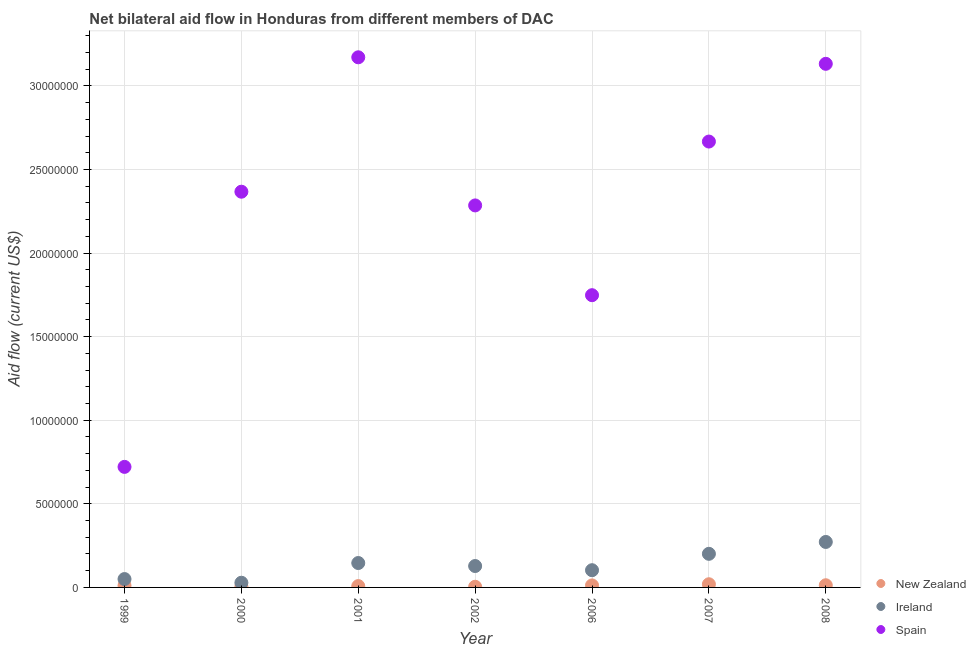Is the number of dotlines equal to the number of legend labels?
Provide a short and direct response. Yes. What is the amount of aid provided by spain in 2007?
Give a very brief answer. 2.67e+07. Across all years, what is the maximum amount of aid provided by new zealand?
Ensure brevity in your answer.  1.90e+05. Across all years, what is the minimum amount of aid provided by ireland?
Ensure brevity in your answer.  2.80e+05. What is the total amount of aid provided by ireland in the graph?
Keep it short and to the point. 9.28e+06. What is the difference between the amount of aid provided by spain in 2001 and that in 2007?
Give a very brief answer. 5.04e+06. What is the difference between the amount of aid provided by ireland in 2007 and the amount of aid provided by new zealand in 2006?
Offer a terse response. 1.89e+06. What is the average amount of aid provided by ireland per year?
Make the answer very short. 1.33e+06. In the year 2001, what is the difference between the amount of aid provided by ireland and amount of aid provided by new zealand?
Make the answer very short. 1.38e+06. What is the ratio of the amount of aid provided by spain in 2000 to that in 2006?
Offer a terse response. 1.35. What is the difference between the highest and the second highest amount of aid provided by ireland?
Give a very brief answer. 7.10e+05. What is the difference between the highest and the lowest amount of aid provided by new zealand?
Provide a short and direct response. 1.50e+05. Is it the case that in every year, the sum of the amount of aid provided by new zealand and amount of aid provided by ireland is greater than the amount of aid provided by spain?
Ensure brevity in your answer.  No. Does the amount of aid provided by new zealand monotonically increase over the years?
Give a very brief answer. No. Is the amount of aid provided by new zealand strictly less than the amount of aid provided by spain over the years?
Provide a short and direct response. Yes. How many years are there in the graph?
Offer a very short reply. 7. Does the graph contain any zero values?
Offer a terse response. No. Does the graph contain grids?
Offer a very short reply. Yes. How many legend labels are there?
Give a very brief answer. 3. How are the legend labels stacked?
Your answer should be very brief. Vertical. What is the title of the graph?
Your response must be concise. Net bilateral aid flow in Honduras from different members of DAC. What is the label or title of the X-axis?
Provide a succinct answer. Year. What is the Aid flow (current US$) in Ireland in 1999?
Your answer should be very brief. 5.00e+05. What is the Aid flow (current US$) in Spain in 1999?
Provide a succinct answer. 7.21e+06. What is the Aid flow (current US$) in New Zealand in 2000?
Offer a terse response. 5.00e+04. What is the Aid flow (current US$) of Ireland in 2000?
Give a very brief answer. 2.80e+05. What is the Aid flow (current US$) of Spain in 2000?
Keep it short and to the point. 2.37e+07. What is the Aid flow (current US$) of Ireland in 2001?
Provide a short and direct response. 1.46e+06. What is the Aid flow (current US$) in Spain in 2001?
Your answer should be compact. 3.17e+07. What is the Aid flow (current US$) of Ireland in 2002?
Keep it short and to the point. 1.28e+06. What is the Aid flow (current US$) of Spain in 2002?
Offer a very short reply. 2.28e+07. What is the Aid flow (current US$) in New Zealand in 2006?
Your answer should be very brief. 1.20e+05. What is the Aid flow (current US$) of Ireland in 2006?
Your response must be concise. 1.03e+06. What is the Aid flow (current US$) of Spain in 2006?
Offer a very short reply. 1.75e+07. What is the Aid flow (current US$) of New Zealand in 2007?
Offer a very short reply. 1.90e+05. What is the Aid flow (current US$) in Ireland in 2007?
Make the answer very short. 2.01e+06. What is the Aid flow (current US$) in Spain in 2007?
Your answer should be very brief. 2.67e+07. What is the Aid flow (current US$) of Ireland in 2008?
Your answer should be compact. 2.72e+06. What is the Aid flow (current US$) of Spain in 2008?
Offer a terse response. 3.13e+07. Across all years, what is the maximum Aid flow (current US$) in Ireland?
Offer a very short reply. 2.72e+06. Across all years, what is the maximum Aid flow (current US$) of Spain?
Your answer should be very brief. 3.17e+07. Across all years, what is the minimum Aid flow (current US$) in New Zealand?
Give a very brief answer. 4.00e+04. Across all years, what is the minimum Aid flow (current US$) of Ireland?
Provide a succinct answer. 2.80e+05. Across all years, what is the minimum Aid flow (current US$) of Spain?
Provide a short and direct response. 7.21e+06. What is the total Aid flow (current US$) in New Zealand in the graph?
Give a very brief answer. 7.20e+05. What is the total Aid flow (current US$) in Ireland in the graph?
Offer a terse response. 9.28e+06. What is the total Aid flow (current US$) in Spain in the graph?
Provide a short and direct response. 1.61e+08. What is the difference between the Aid flow (current US$) of Spain in 1999 and that in 2000?
Offer a terse response. -1.65e+07. What is the difference between the Aid flow (current US$) in New Zealand in 1999 and that in 2001?
Your answer should be very brief. 3.00e+04. What is the difference between the Aid flow (current US$) of Ireland in 1999 and that in 2001?
Offer a terse response. -9.60e+05. What is the difference between the Aid flow (current US$) in Spain in 1999 and that in 2001?
Keep it short and to the point. -2.45e+07. What is the difference between the Aid flow (current US$) in Ireland in 1999 and that in 2002?
Your answer should be very brief. -7.80e+05. What is the difference between the Aid flow (current US$) in Spain in 1999 and that in 2002?
Provide a short and direct response. -1.56e+07. What is the difference between the Aid flow (current US$) of Ireland in 1999 and that in 2006?
Provide a short and direct response. -5.30e+05. What is the difference between the Aid flow (current US$) in Spain in 1999 and that in 2006?
Make the answer very short. -1.03e+07. What is the difference between the Aid flow (current US$) of Ireland in 1999 and that in 2007?
Provide a short and direct response. -1.51e+06. What is the difference between the Aid flow (current US$) in Spain in 1999 and that in 2007?
Make the answer very short. -1.95e+07. What is the difference between the Aid flow (current US$) in Ireland in 1999 and that in 2008?
Offer a very short reply. -2.22e+06. What is the difference between the Aid flow (current US$) in Spain in 1999 and that in 2008?
Your answer should be very brief. -2.41e+07. What is the difference between the Aid flow (current US$) of New Zealand in 2000 and that in 2001?
Give a very brief answer. -3.00e+04. What is the difference between the Aid flow (current US$) in Ireland in 2000 and that in 2001?
Provide a succinct answer. -1.18e+06. What is the difference between the Aid flow (current US$) in Spain in 2000 and that in 2001?
Make the answer very short. -8.04e+06. What is the difference between the Aid flow (current US$) of Ireland in 2000 and that in 2002?
Your answer should be compact. -1.00e+06. What is the difference between the Aid flow (current US$) in Spain in 2000 and that in 2002?
Provide a short and direct response. 8.20e+05. What is the difference between the Aid flow (current US$) in New Zealand in 2000 and that in 2006?
Keep it short and to the point. -7.00e+04. What is the difference between the Aid flow (current US$) in Ireland in 2000 and that in 2006?
Provide a succinct answer. -7.50e+05. What is the difference between the Aid flow (current US$) of Spain in 2000 and that in 2006?
Your answer should be compact. 6.19e+06. What is the difference between the Aid flow (current US$) in Ireland in 2000 and that in 2007?
Your answer should be very brief. -1.73e+06. What is the difference between the Aid flow (current US$) of New Zealand in 2000 and that in 2008?
Provide a short and direct response. -8.00e+04. What is the difference between the Aid flow (current US$) in Ireland in 2000 and that in 2008?
Give a very brief answer. -2.44e+06. What is the difference between the Aid flow (current US$) in Spain in 2000 and that in 2008?
Your answer should be very brief. -7.65e+06. What is the difference between the Aid flow (current US$) of Spain in 2001 and that in 2002?
Ensure brevity in your answer.  8.86e+06. What is the difference between the Aid flow (current US$) of New Zealand in 2001 and that in 2006?
Provide a succinct answer. -4.00e+04. What is the difference between the Aid flow (current US$) in Ireland in 2001 and that in 2006?
Offer a very short reply. 4.30e+05. What is the difference between the Aid flow (current US$) of Spain in 2001 and that in 2006?
Keep it short and to the point. 1.42e+07. What is the difference between the Aid flow (current US$) of Ireland in 2001 and that in 2007?
Offer a very short reply. -5.50e+05. What is the difference between the Aid flow (current US$) of Spain in 2001 and that in 2007?
Give a very brief answer. 5.04e+06. What is the difference between the Aid flow (current US$) of Ireland in 2001 and that in 2008?
Give a very brief answer. -1.26e+06. What is the difference between the Aid flow (current US$) of New Zealand in 2002 and that in 2006?
Your answer should be compact. -8.00e+04. What is the difference between the Aid flow (current US$) in Spain in 2002 and that in 2006?
Your response must be concise. 5.37e+06. What is the difference between the Aid flow (current US$) in Ireland in 2002 and that in 2007?
Provide a succinct answer. -7.30e+05. What is the difference between the Aid flow (current US$) of Spain in 2002 and that in 2007?
Offer a very short reply. -3.82e+06. What is the difference between the Aid flow (current US$) of New Zealand in 2002 and that in 2008?
Offer a terse response. -9.00e+04. What is the difference between the Aid flow (current US$) in Ireland in 2002 and that in 2008?
Ensure brevity in your answer.  -1.44e+06. What is the difference between the Aid flow (current US$) of Spain in 2002 and that in 2008?
Offer a terse response. -8.47e+06. What is the difference between the Aid flow (current US$) in New Zealand in 2006 and that in 2007?
Your answer should be very brief. -7.00e+04. What is the difference between the Aid flow (current US$) of Ireland in 2006 and that in 2007?
Offer a terse response. -9.80e+05. What is the difference between the Aid flow (current US$) of Spain in 2006 and that in 2007?
Provide a short and direct response. -9.19e+06. What is the difference between the Aid flow (current US$) in Ireland in 2006 and that in 2008?
Provide a short and direct response. -1.69e+06. What is the difference between the Aid flow (current US$) of Spain in 2006 and that in 2008?
Offer a terse response. -1.38e+07. What is the difference between the Aid flow (current US$) of Ireland in 2007 and that in 2008?
Ensure brevity in your answer.  -7.10e+05. What is the difference between the Aid flow (current US$) of Spain in 2007 and that in 2008?
Provide a succinct answer. -4.65e+06. What is the difference between the Aid flow (current US$) of New Zealand in 1999 and the Aid flow (current US$) of Ireland in 2000?
Make the answer very short. -1.70e+05. What is the difference between the Aid flow (current US$) in New Zealand in 1999 and the Aid flow (current US$) in Spain in 2000?
Make the answer very short. -2.36e+07. What is the difference between the Aid flow (current US$) in Ireland in 1999 and the Aid flow (current US$) in Spain in 2000?
Give a very brief answer. -2.32e+07. What is the difference between the Aid flow (current US$) of New Zealand in 1999 and the Aid flow (current US$) of Ireland in 2001?
Keep it short and to the point. -1.35e+06. What is the difference between the Aid flow (current US$) of New Zealand in 1999 and the Aid flow (current US$) of Spain in 2001?
Keep it short and to the point. -3.16e+07. What is the difference between the Aid flow (current US$) of Ireland in 1999 and the Aid flow (current US$) of Spain in 2001?
Provide a succinct answer. -3.12e+07. What is the difference between the Aid flow (current US$) in New Zealand in 1999 and the Aid flow (current US$) in Ireland in 2002?
Offer a very short reply. -1.17e+06. What is the difference between the Aid flow (current US$) in New Zealand in 1999 and the Aid flow (current US$) in Spain in 2002?
Give a very brief answer. -2.27e+07. What is the difference between the Aid flow (current US$) in Ireland in 1999 and the Aid flow (current US$) in Spain in 2002?
Your response must be concise. -2.24e+07. What is the difference between the Aid flow (current US$) of New Zealand in 1999 and the Aid flow (current US$) of Ireland in 2006?
Provide a succinct answer. -9.20e+05. What is the difference between the Aid flow (current US$) in New Zealand in 1999 and the Aid flow (current US$) in Spain in 2006?
Ensure brevity in your answer.  -1.74e+07. What is the difference between the Aid flow (current US$) of Ireland in 1999 and the Aid flow (current US$) of Spain in 2006?
Your answer should be compact. -1.70e+07. What is the difference between the Aid flow (current US$) in New Zealand in 1999 and the Aid flow (current US$) in Ireland in 2007?
Offer a very short reply. -1.90e+06. What is the difference between the Aid flow (current US$) of New Zealand in 1999 and the Aid flow (current US$) of Spain in 2007?
Your answer should be compact. -2.66e+07. What is the difference between the Aid flow (current US$) of Ireland in 1999 and the Aid flow (current US$) of Spain in 2007?
Offer a very short reply. -2.62e+07. What is the difference between the Aid flow (current US$) in New Zealand in 1999 and the Aid flow (current US$) in Ireland in 2008?
Keep it short and to the point. -2.61e+06. What is the difference between the Aid flow (current US$) of New Zealand in 1999 and the Aid flow (current US$) of Spain in 2008?
Keep it short and to the point. -3.12e+07. What is the difference between the Aid flow (current US$) of Ireland in 1999 and the Aid flow (current US$) of Spain in 2008?
Make the answer very short. -3.08e+07. What is the difference between the Aid flow (current US$) of New Zealand in 2000 and the Aid flow (current US$) of Ireland in 2001?
Your answer should be compact. -1.41e+06. What is the difference between the Aid flow (current US$) of New Zealand in 2000 and the Aid flow (current US$) of Spain in 2001?
Your response must be concise. -3.17e+07. What is the difference between the Aid flow (current US$) of Ireland in 2000 and the Aid flow (current US$) of Spain in 2001?
Make the answer very short. -3.14e+07. What is the difference between the Aid flow (current US$) of New Zealand in 2000 and the Aid flow (current US$) of Ireland in 2002?
Your answer should be compact. -1.23e+06. What is the difference between the Aid flow (current US$) in New Zealand in 2000 and the Aid flow (current US$) in Spain in 2002?
Provide a short and direct response. -2.28e+07. What is the difference between the Aid flow (current US$) of Ireland in 2000 and the Aid flow (current US$) of Spain in 2002?
Your response must be concise. -2.26e+07. What is the difference between the Aid flow (current US$) of New Zealand in 2000 and the Aid flow (current US$) of Ireland in 2006?
Make the answer very short. -9.80e+05. What is the difference between the Aid flow (current US$) in New Zealand in 2000 and the Aid flow (current US$) in Spain in 2006?
Make the answer very short. -1.74e+07. What is the difference between the Aid flow (current US$) in Ireland in 2000 and the Aid flow (current US$) in Spain in 2006?
Offer a terse response. -1.72e+07. What is the difference between the Aid flow (current US$) in New Zealand in 2000 and the Aid flow (current US$) in Ireland in 2007?
Your answer should be compact. -1.96e+06. What is the difference between the Aid flow (current US$) in New Zealand in 2000 and the Aid flow (current US$) in Spain in 2007?
Keep it short and to the point. -2.66e+07. What is the difference between the Aid flow (current US$) of Ireland in 2000 and the Aid flow (current US$) of Spain in 2007?
Offer a terse response. -2.64e+07. What is the difference between the Aid flow (current US$) of New Zealand in 2000 and the Aid flow (current US$) of Ireland in 2008?
Ensure brevity in your answer.  -2.67e+06. What is the difference between the Aid flow (current US$) of New Zealand in 2000 and the Aid flow (current US$) of Spain in 2008?
Provide a short and direct response. -3.13e+07. What is the difference between the Aid flow (current US$) in Ireland in 2000 and the Aid flow (current US$) in Spain in 2008?
Keep it short and to the point. -3.10e+07. What is the difference between the Aid flow (current US$) of New Zealand in 2001 and the Aid flow (current US$) of Ireland in 2002?
Give a very brief answer. -1.20e+06. What is the difference between the Aid flow (current US$) of New Zealand in 2001 and the Aid flow (current US$) of Spain in 2002?
Your response must be concise. -2.28e+07. What is the difference between the Aid flow (current US$) of Ireland in 2001 and the Aid flow (current US$) of Spain in 2002?
Keep it short and to the point. -2.14e+07. What is the difference between the Aid flow (current US$) of New Zealand in 2001 and the Aid flow (current US$) of Ireland in 2006?
Offer a terse response. -9.50e+05. What is the difference between the Aid flow (current US$) in New Zealand in 2001 and the Aid flow (current US$) in Spain in 2006?
Make the answer very short. -1.74e+07. What is the difference between the Aid flow (current US$) of Ireland in 2001 and the Aid flow (current US$) of Spain in 2006?
Offer a very short reply. -1.60e+07. What is the difference between the Aid flow (current US$) of New Zealand in 2001 and the Aid flow (current US$) of Ireland in 2007?
Make the answer very short. -1.93e+06. What is the difference between the Aid flow (current US$) of New Zealand in 2001 and the Aid flow (current US$) of Spain in 2007?
Keep it short and to the point. -2.66e+07. What is the difference between the Aid flow (current US$) of Ireland in 2001 and the Aid flow (current US$) of Spain in 2007?
Give a very brief answer. -2.52e+07. What is the difference between the Aid flow (current US$) in New Zealand in 2001 and the Aid flow (current US$) in Ireland in 2008?
Give a very brief answer. -2.64e+06. What is the difference between the Aid flow (current US$) of New Zealand in 2001 and the Aid flow (current US$) of Spain in 2008?
Offer a very short reply. -3.12e+07. What is the difference between the Aid flow (current US$) of Ireland in 2001 and the Aid flow (current US$) of Spain in 2008?
Your answer should be compact. -2.99e+07. What is the difference between the Aid flow (current US$) in New Zealand in 2002 and the Aid flow (current US$) in Ireland in 2006?
Provide a short and direct response. -9.90e+05. What is the difference between the Aid flow (current US$) of New Zealand in 2002 and the Aid flow (current US$) of Spain in 2006?
Offer a terse response. -1.74e+07. What is the difference between the Aid flow (current US$) of Ireland in 2002 and the Aid flow (current US$) of Spain in 2006?
Your answer should be very brief. -1.62e+07. What is the difference between the Aid flow (current US$) of New Zealand in 2002 and the Aid flow (current US$) of Ireland in 2007?
Provide a short and direct response. -1.97e+06. What is the difference between the Aid flow (current US$) in New Zealand in 2002 and the Aid flow (current US$) in Spain in 2007?
Your answer should be compact. -2.66e+07. What is the difference between the Aid flow (current US$) of Ireland in 2002 and the Aid flow (current US$) of Spain in 2007?
Provide a succinct answer. -2.54e+07. What is the difference between the Aid flow (current US$) of New Zealand in 2002 and the Aid flow (current US$) of Ireland in 2008?
Keep it short and to the point. -2.68e+06. What is the difference between the Aid flow (current US$) of New Zealand in 2002 and the Aid flow (current US$) of Spain in 2008?
Provide a short and direct response. -3.13e+07. What is the difference between the Aid flow (current US$) in Ireland in 2002 and the Aid flow (current US$) in Spain in 2008?
Provide a short and direct response. -3.00e+07. What is the difference between the Aid flow (current US$) in New Zealand in 2006 and the Aid flow (current US$) in Ireland in 2007?
Your answer should be compact. -1.89e+06. What is the difference between the Aid flow (current US$) in New Zealand in 2006 and the Aid flow (current US$) in Spain in 2007?
Your response must be concise. -2.66e+07. What is the difference between the Aid flow (current US$) in Ireland in 2006 and the Aid flow (current US$) in Spain in 2007?
Provide a succinct answer. -2.56e+07. What is the difference between the Aid flow (current US$) in New Zealand in 2006 and the Aid flow (current US$) in Ireland in 2008?
Ensure brevity in your answer.  -2.60e+06. What is the difference between the Aid flow (current US$) of New Zealand in 2006 and the Aid flow (current US$) of Spain in 2008?
Give a very brief answer. -3.12e+07. What is the difference between the Aid flow (current US$) of Ireland in 2006 and the Aid flow (current US$) of Spain in 2008?
Offer a very short reply. -3.03e+07. What is the difference between the Aid flow (current US$) in New Zealand in 2007 and the Aid flow (current US$) in Ireland in 2008?
Provide a short and direct response. -2.53e+06. What is the difference between the Aid flow (current US$) of New Zealand in 2007 and the Aid flow (current US$) of Spain in 2008?
Offer a very short reply. -3.11e+07. What is the difference between the Aid flow (current US$) in Ireland in 2007 and the Aid flow (current US$) in Spain in 2008?
Your response must be concise. -2.93e+07. What is the average Aid flow (current US$) of New Zealand per year?
Give a very brief answer. 1.03e+05. What is the average Aid flow (current US$) of Ireland per year?
Offer a very short reply. 1.33e+06. What is the average Aid flow (current US$) of Spain per year?
Ensure brevity in your answer.  2.30e+07. In the year 1999, what is the difference between the Aid flow (current US$) of New Zealand and Aid flow (current US$) of Ireland?
Your answer should be compact. -3.90e+05. In the year 1999, what is the difference between the Aid flow (current US$) in New Zealand and Aid flow (current US$) in Spain?
Your response must be concise. -7.10e+06. In the year 1999, what is the difference between the Aid flow (current US$) of Ireland and Aid flow (current US$) of Spain?
Keep it short and to the point. -6.71e+06. In the year 2000, what is the difference between the Aid flow (current US$) in New Zealand and Aid flow (current US$) in Ireland?
Your answer should be very brief. -2.30e+05. In the year 2000, what is the difference between the Aid flow (current US$) of New Zealand and Aid flow (current US$) of Spain?
Give a very brief answer. -2.36e+07. In the year 2000, what is the difference between the Aid flow (current US$) in Ireland and Aid flow (current US$) in Spain?
Ensure brevity in your answer.  -2.34e+07. In the year 2001, what is the difference between the Aid flow (current US$) of New Zealand and Aid flow (current US$) of Ireland?
Offer a terse response. -1.38e+06. In the year 2001, what is the difference between the Aid flow (current US$) in New Zealand and Aid flow (current US$) in Spain?
Make the answer very short. -3.16e+07. In the year 2001, what is the difference between the Aid flow (current US$) of Ireland and Aid flow (current US$) of Spain?
Ensure brevity in your answer.  -3.02e+07. In the year 2002, what is the difference between the Aid flow (current US$) of New Zealand and Aid flow (current US$) of Ireland?
Your response must be concise. -1.24e+06. In the year 2002, what is the difference between the Aid flow (current US$) in New Zealand and Aid flow (current US$) in Spain?
Give a very brief answer. -2.28e+07. In the year 2002, what is the difference between the Aid flow (current US$) in Ireland and Aid flow (current US$) in Spain?
Provide a succinct answer. -2.16e+07. In the year 2006, what is the difference between the Aid flow (current US$) of New Zealand and Aid flow (current US$) of Ireland?
Your response must be concise. -9.10e+05. In the year 2006, what is the difference between the Aid flow (current US$) of New Zealand and Aid flow (current US$) of Spain?
Provide a succinct answer. -1.74e+07. In the year 2006, what is the difference between the Aid flow (current US$) of Ireland and Aid flow (current US$) of Spain?
Offer a very short reply. -1.64e+07. In the year 2007, what is the difference between the Aid flow (current US$) in New Zealand and Aid flow (current US$) in Ireland?
Your answer should be very brief. -1.82e+06. In the year 2007, what is the difference between the Aid flow (current US$) of New Zealand and Aid flow (current US$) of Spain?
Make the answer very short. -2.65e+07. In the year 2007, what is the difference between the Aid flow (current US$) of Ireland and Aid flow (current US$) of Spain?
Provide a short and direct response. -2.47e+07. In the year 2008, what is the difference between the Aid flow (current US$) of New Zealand and Aid flow (current US$) of Ireland?
Your answer should be compact. -2.59e+06. In the year 2008, what is the difference between the Aid flow (current US$) in New Zealand and Aid flow (current US$) in Spain?
Your answer should be very brief. -3.12e+07. In the year 2008, what is the difference between the Aid flow (current US$) of Ireland and Aid flow (current US$) of Spain?
Your response must be concise. -2.86e+07. What is the ratio of the Aid flow (current US$) in New Zealand in 1999 to that in 2000?
Offer a very short reply. 2.2. What is the ratio of the Aid flow (current US$) in Ireland in 1999 to that in 2000?
Offer a terse response. 1.79. What is the ratio of the Aid flow (current US$) in Spain in 1999 to that in 2000?
Give a very brief answer. 0.3. What is the ratio of the Aid flow (current US$) in New Zealand in 1999 to that in 2001?
Offer a terse response. 1.38. What is the ratio of the Aid flow (current US$) in Ireland in 1999 to that in 2001?
Keep it short and to the point. 0.34. What is the ratio of the Aid flow (current US$) of Spain in 1999 to that in 2001?
Ensure brevity in your answer.  0.23. What is the ratio of the Aid flow (current US$) of New Zealand in 1999 to that in 2002?
Your answer should be very brief. 2.75. What is the ratio of the Aid flow (current US$) in Ireland in 1999 to that in 2002?
Give a very brief answer. 0.39. What is the ratio of the Aid flow (current US$) in Spain in 1999 to that in 2002?
Your answer should be very brief. 0.32. What is the ratio of the Aid flow (current US$) in Ireland in 1999 to that in 2006?
Ensure brevity in your answer.  0.49. What is the ratio of the Aid flow (current US$) in Spain in 1999 to that in 2006?
Your response must be concise. 0.41. What is the ratio of the Aid flow (current US$) in New Zealand in 1999 to that in 2007?
Your answer should be very brief. 0.58. What is the ratio of the Aid flow (current US$) in Ireland in 1999 to that in 2007?
Offer a terse response. 0.25. What is the ratio of the Aid flow (current US$) in Spain in 1999 to that in 2007?
Give a very brief answer. 0.27. What is the ratio of the Aid flow (current US$) of New Zealand in 1999 to that in 2008?
Ensure brevity in your answer.  0.85. What is the ratio of the Aid flow (current US$) in Ireland in 1999 to that in 2008?
Your answer should be compact. 0.18. What is the ratio of the Aid flow (current US$) of Spain in 1999 to that in 2008?
Provide a short and direct response. 0.23. What is the ratio of the Aid flow (current US$) of Ireland in 2000 to that in 2001?
Offer a very short reply. 0.19. What is the ratio of the Aid flow (current US$) in Spain in 2000 to that in 2001?
Offer a terse response. 0.75. What is the ratio of the Aid flow (current US$) of Ireland in 2000 to that in 2002?
Provide a short and direct response. 0.22. What is the ratio of the Aid flow (current US$) of Spain in 2000 to that in 2002?
Your answer should be compact. 1.04. What is the ratio of the Aid flow (current US$) in New Zealand in 2000 to that in 2006?
Ensure brevity in your answer.  0.42. What is the ratio of the Aid flow (current US$) of Ireland in 2000 to that in 2006?
Keep it short and to the point. 0.27. What is the ratio of the Aid flow (current US$) of Spain in 2000 to that in 2006?
Your response must be concise. 1.35. What is the ratio of the Aid flow (current US$) in New Zealand in 2000 to that in 2007?
Your response must be concise. 0.26. What is the ratio of the Aid flow (current US$) of Ireland in 2000 to that in 2007?
Give a very brief answer. 0.14. What is the ratio of the Aid flow (current US$) of Spain in 2000 to that in 2007?
Your answer should be very brief. 0.89. What is the ratio of the Aid flow (current US$) of New Zealand in 2000 to that in 2008?
Keep it short and to the point. 0.38. What is the ratio of the Aid flow (current US$) of Ireland in 2000 to that in 2008?
Give a very brief answer. 0.1. What is the ratio of the Aid flow (current US$) of Spain in 2000 to that in 2008?
Provide a succinct answer. 0.76. What is the ratio of the Aid flow (current US$) in New Zealand in 2001 to that in 2002?
Your response must be concise. 2. What is the ratio of the Aid flow (current US$) of Ireland in 2001 to that in 2002?
Provide a succinct answer. 1.14. What is the ratio of the Aid flow (current US$) in Spain in 2001 to that in 2002?
Offer a terse response. 1.39. What is the ratio of the Aid flow (current US$) in Ireland in 2001 to that in 2006?
Keep it short and to the point. 1.42. What is the ratio of the Aid flow (current US$) of Spain in 2001 to that in 2006?
Ensure brevity in your answer.  1.81. What is the ratio of the Aid flow (current US$) in New Zealand in 2001 to that in 2007?
Ensure brevity in your answer.  0.42. What is the ratio of the Aid flow (current US$) in Ireland in 2001 to that in 2007?
Offer a very short reply. 0.73. What is the ratio of the Aid flow (current US$) of Spain in 2001 to that in 2007?
Your answer should be compact. 1.19. What is the ratio of the Aid flow (current US$) in New Zealand in 2001 to that in 2008?
Your response must be concise. 0.62. What is the ratio of the Aid flow (current US$) in Ireland in 2001 to that in 2008?
Make the answer very short. 0.54. What is the ratio of the Aid flow (current US$) of Spain in 2001 to that in 2008?
Ensure brevity in your answer.  1.01. What is the ratio of the Aid flow (current US$) in New Zealand in 2002 to that in 2006?
Provide a succinct answer. 0.33. What is the ratio of the Aid flow (current US$) in Ireland in 2002 to that in 2006?
Offer a terse response. 1.24. What is the ratio of the Aid flow (current US$) of Spain in 2002 to that in 2006?
Provide a short and direct response. 1.31. What is the ratio of the Aid flow (current US$) of New Zealand in 2002 to that in 2007?
Your response must be concise. 0.21. What is the ratio of the Aid flow (current US$) in Ireland in 2002 to that in 2007?
Your response must be concise. 0.64. What is the ratio of the Aid flow (current US$) of Spain in 2002 to that in 2007?
Your answer should be very brief. 0.86. What is the ratio of the Aid flow (current US$) in New Zealand in 2002 to that in 2008?
Provide a short and direct response. 0.31. What is the ratio of the Aid flow (current US$) in Ireland in 2002 to that in 2008?
Make the answer very short. 0.47. What is the ratio of the Aid flow (current US$) of Spain in 2002 to that in 2008?
Offer a terse response. 0.73. What is the ratio of the Aid flow (current US$) of New Zealand in 2006 to that in 2007?
Give a very brief answer. 0.63. What is the ratio of the Aid flow (current US$) in Ireland in 2006 to that in 2007?
Your response must be concise. 0.51. What is the ratio of the Aid flow (current US$) of Spain in 2006 to that in 2007?
Make the answer very short. 0.66. What is the ratio of the Aid flow (current US$) in Ireland in 2006 to that in 2008?
Your answer should be very brief. 0.38. What is the ratio of the Aid flow (current US$) of Spain in 2006 to that in 2008?
Your answer should be compact. 0.56. What is the ratio of the Aid flow (current US$) in New Zealand in 2007 to that in 2008?
Offer a terse response. 1.46. What is the ratio of the Aid flow (current US$) in Ireland in 2007 to that in 2008?
Provide a short and direct response. 0.74. What is the ratio of the Aid flow (current US$) of Spain in 2007 to that in 2008?
Your answer should be compact. 0.85. What is the difference between the highest and the second highest Aid flow (current US$) of New Zealand?
Keep it short and to the point. 6.00e+04. What is the difference between the highest and the second highest Aid flow (current US$) in Ireland?
Provide a short and direct response. 7.10e+05. What is the difference between the highest and the lowest Aid flow (current US$) in New Zealand?
Offer a terse response. 1.50e+05. What is the difference between the highest and the lowest Aid flow (current US$) in Ireland?
Provide a short and direct response. 2.44e+06. What is the difference between the highest and the lowest Aid flow (current US$) in Spain?
Make the answer very short. 2.45e+07. 